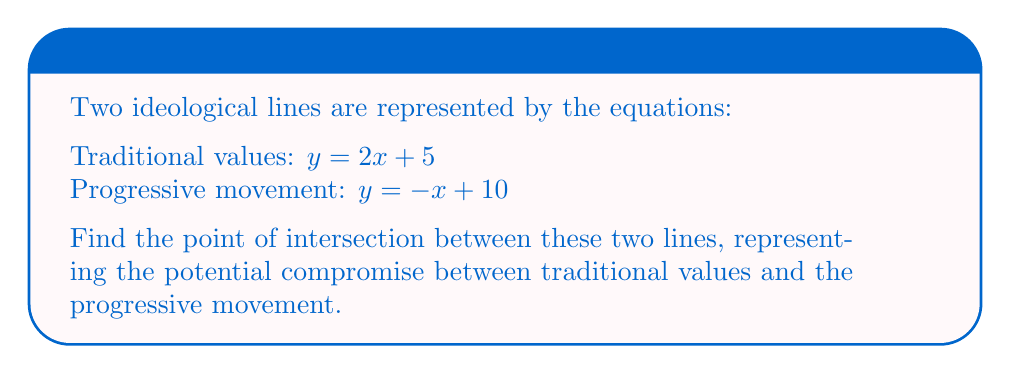Could you help me with this problem? To find the intersection point of two lines, we need to solve the system of equations:

$$\begin{cases}
y = 2x + 5 \\
y = -x + 10
\end{cases}$$

1) Since both equations are equal to $y$, we can set them equal to each other:

   $2x + 5 = -x + 10$

2) Add $x$ to both sides:
   
   $3x + 5 = 10$

3) Subtract 5 from both sides:
   
   $3x = 5$

4) Divide both sides by 3:
   
   $x = \frac{5}{3}$

5) Now that we have $x$, we can substitute it into either of the original equations. Let's use the first one:

   $y = 2(\frac{5}{3}) + 5$

6) Simplify:
   
   $y = \frac{10}{3} + 5 = \frac{10}{3} + \frac{15}{3} = \frac{25}{3}$

Therefore, the point of intersection is $(\frac{5}{3}, \frac{25}{3})$.

[asy]
import geometry;

size(200);
real xmin = -1, xmax = 6, ymin = -1, ymax = 12;
axes("x", "y", xmin, xmax, ymin, ymax, Arrow);

real f(real x) {return 2x + 5;}
real g(real x) {return -x + 10;}

draw(graph(f, xmin, xmax), blue, "Traditional values");
draw(graph(g, xmin, xmax), red, "Progressive movement");

dot((5/3, 25/3), black);
label("(5/3, 25/3)", (5/3, 25/3), NE);
[/asy]
Answer: The point of intersection is $(\frac{5}{3}, \frac{25}{3})$. 